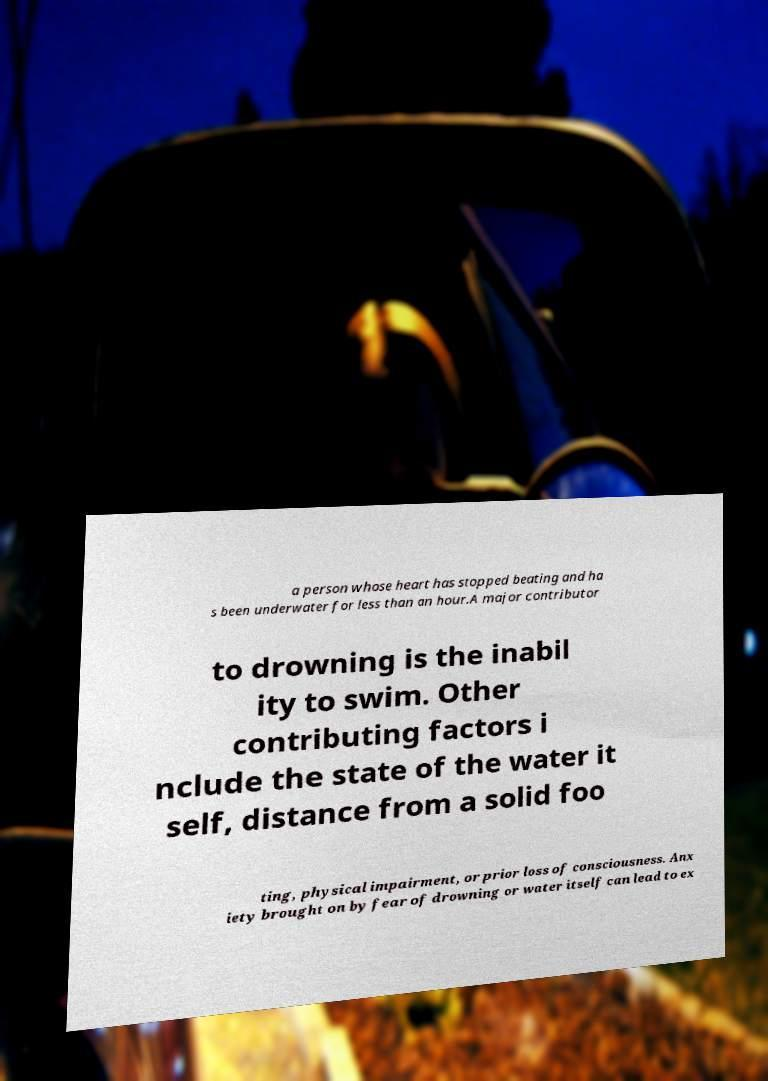Please identify and transcribe the text found in this image. a person whose heart has stopped beating and ha s been underwater for less than an hour.A major contributor to drowning is the inabil ity to swim. Other contributing factors i nclude the state of the water it self, distance from a solid foo ting, physical impairment, or prior loss of consciousness. Anx iety brought on by fear of drowning or water itself can lead to ex 